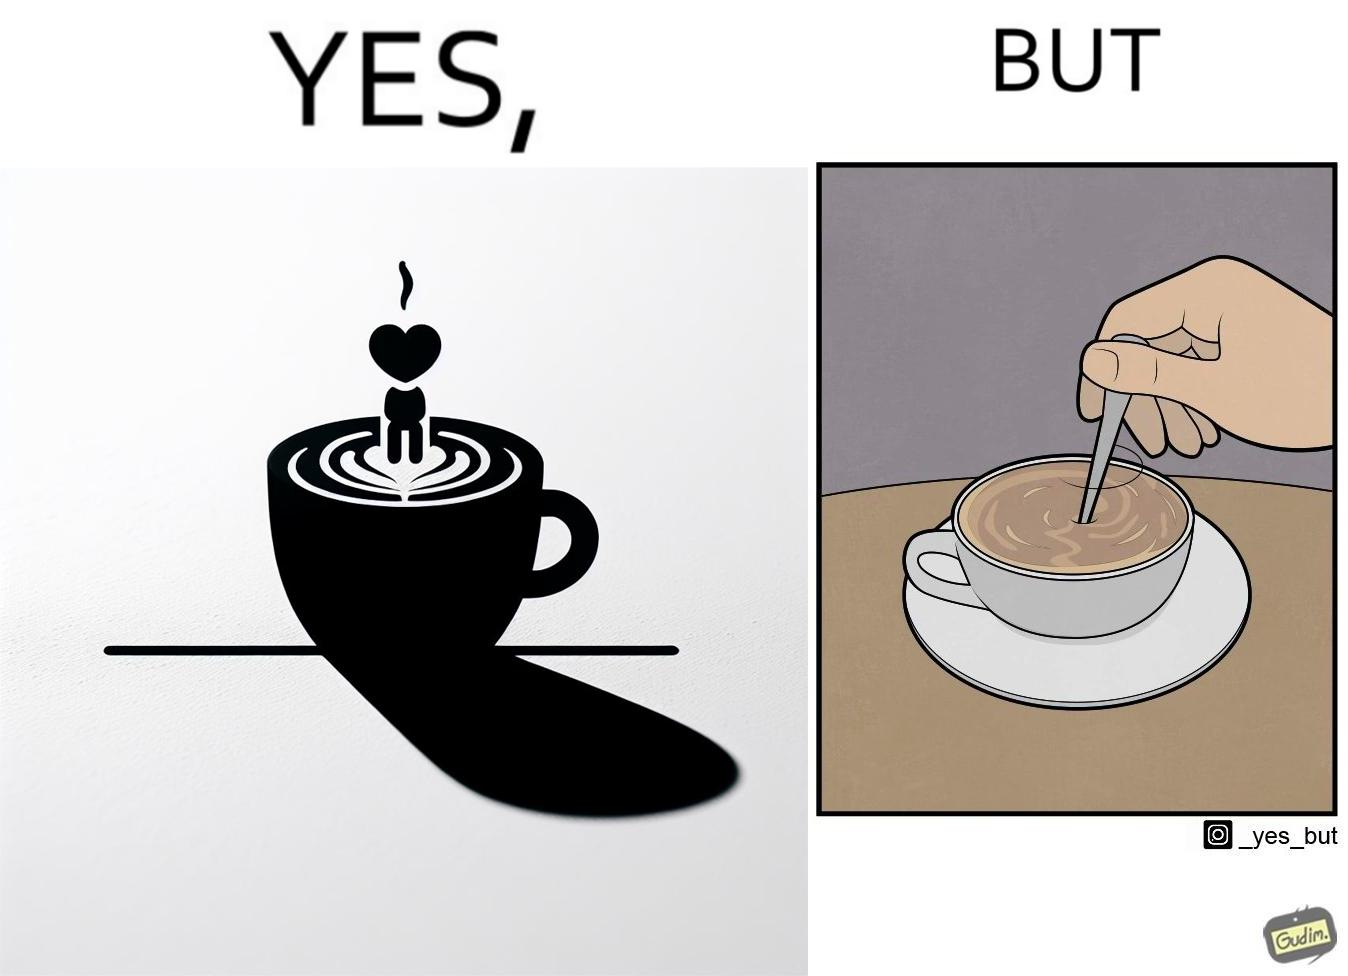Describe the satirical element in this image. The image is ironic, because even when the coffee maker create latte art to make coffee look attractive but it is there just for a short time after that it is vanished 